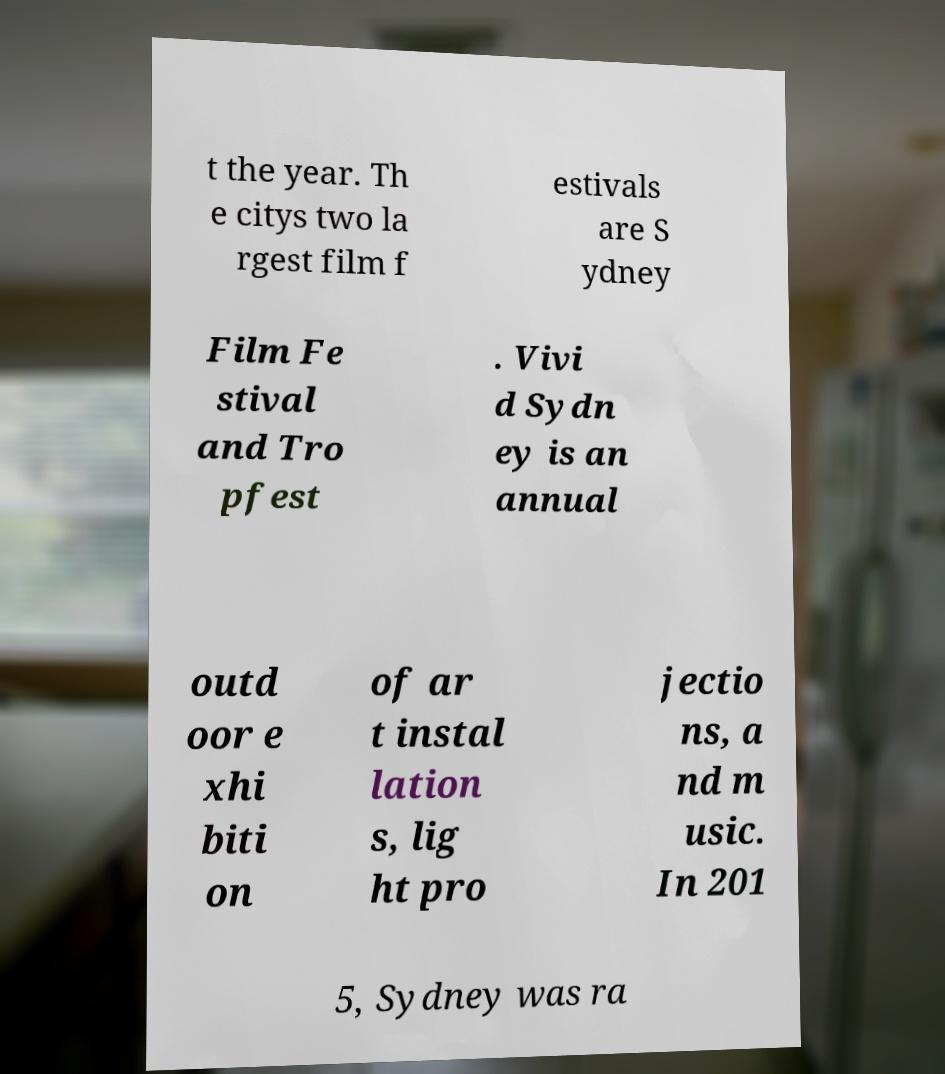Could you assist in decoding the text presented in this image and type it out clearly? t the year. Th e citys two la rgest film f estivals are S ydney Film Fe stival and Tro pfest . Vivi d Sydn ey is an annual outd oor e xhi biti on of ar t instal lation s, lig ht pro jectio ns, a nd m usic. In 201 5, Sydney was ra 